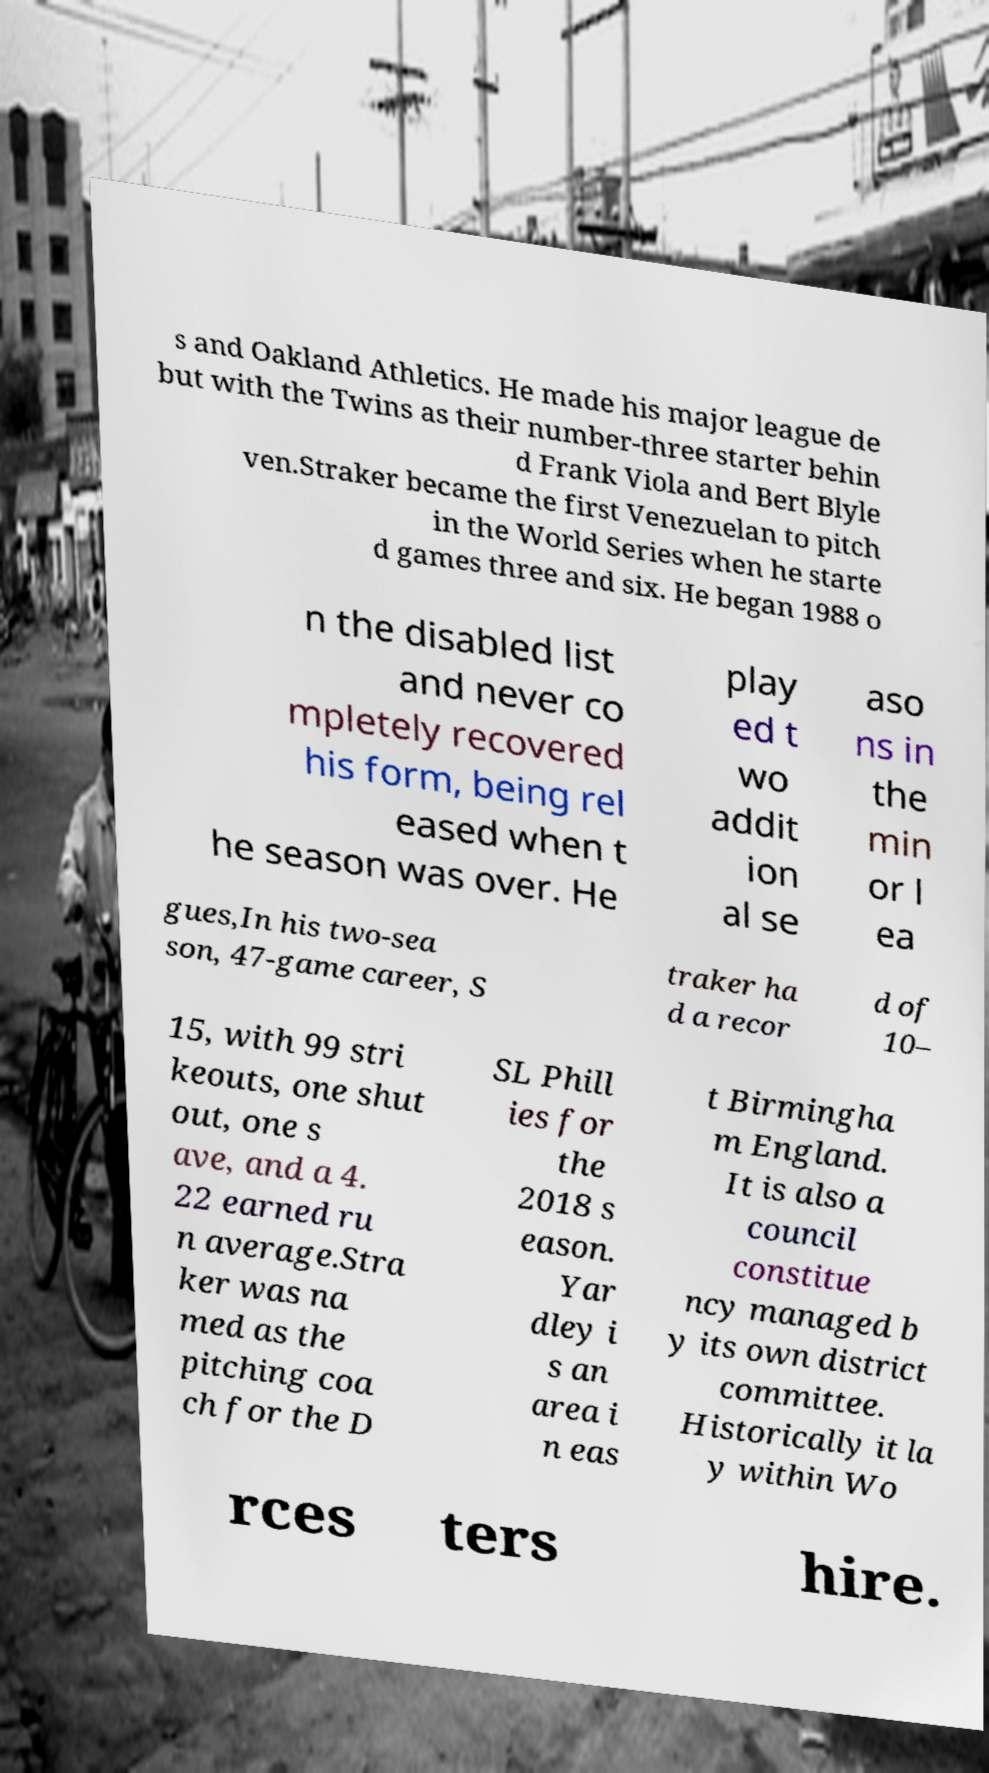For documentation purposes, I need the text within this image transcribed. Could you provide that? s and Oakland Athletics. He made his major league de but with the Twins as their number-three starter behin d Frank Viola and Bert Blyle ven.Straker became the first Venezuelan to pitch in the World Series when he starte d games three and six. He began 1988 o n the disabled list and never co mpletely recovered his form, being rel eased when t he season was over. He play ed t wo addit ion al se aso ns in the min or l ea gues,In his two-sea son, 47-game career, S traker ha d a recor d of 10– 15, with 99 stri keouts, one shut out, one s ave, and a 4. 22 earned ru n average.Stra ker was na med as the pitching coa ch for the D SL Phill ies for the 2018 s eason. Yar dley i s an area i n eas t Birmingha m England. It is also a council constitue ncy managed b y its own district committee. Historically it la y within Wo rces ters hire. 